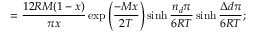<formula> <loc_0><loc_0><loc_500><loc_500>= \frac { 1 2 R M ( 1 - x ) } { \pi x } \exp { \left ( \frac { - M x } { 2 T } \right ) } \sinh { \frac { n _ { d } \pi } { 6 R T } } \sinh { \frac { \Delta d \pi } { 6 R T } } ;</formula> 